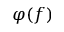<formula> <loc_0><loc_0><loc_500><loc_500>\varphi ( f )</formula> 